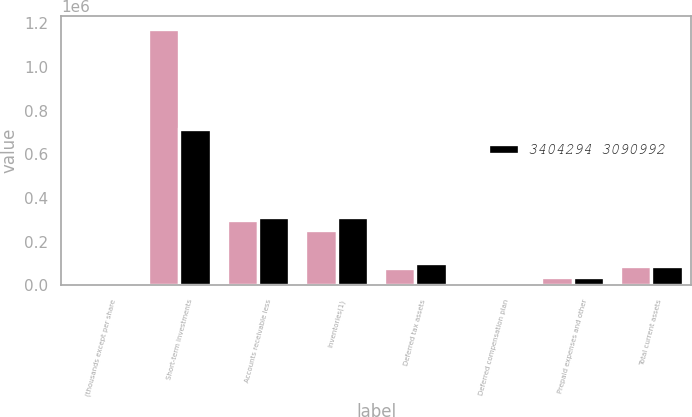<chart> <loc_0><loc_0><loc_500><loc_500><stacked_bar_chart><ecel><fcel>(thousands except per share<fcel>Short-term investments<fcel>Accounts receivable less<fcel>Inventories(1)<fcel>Deferred tax assets<fcel>Deferred compensation plan<fcel>Prepaid expenses and other<fcel>Total current assets<nl><fcel>nan<fcel>2009<fcel>1.17624e+06<fcel>301036<fcel>253161<fcel>78740<fcel>1363<fcel>40363<fcel>90708<nl><fcel>3404294 3090992<fcel>2008<fcel>716087<fcel>315290<fcel>314629<fcel>102676<fcel>942<fcel>40460<fcel>90708<nl></chart> 